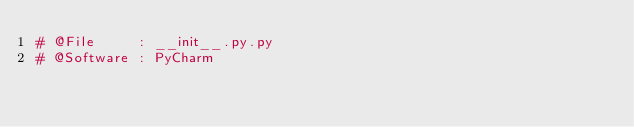Convert code to text. <code><loc_0><loc_0><loc_500><loc_500><_Python_># @File     : __init__.py.py
# @Software : PyCharm
</code> 